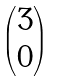Convert formula to latex. <formula><loc_0><loc_0><loc_500><loc_500>\begin{pmatrix} 3 \\ 0 \end{pmatrix}</formula> 